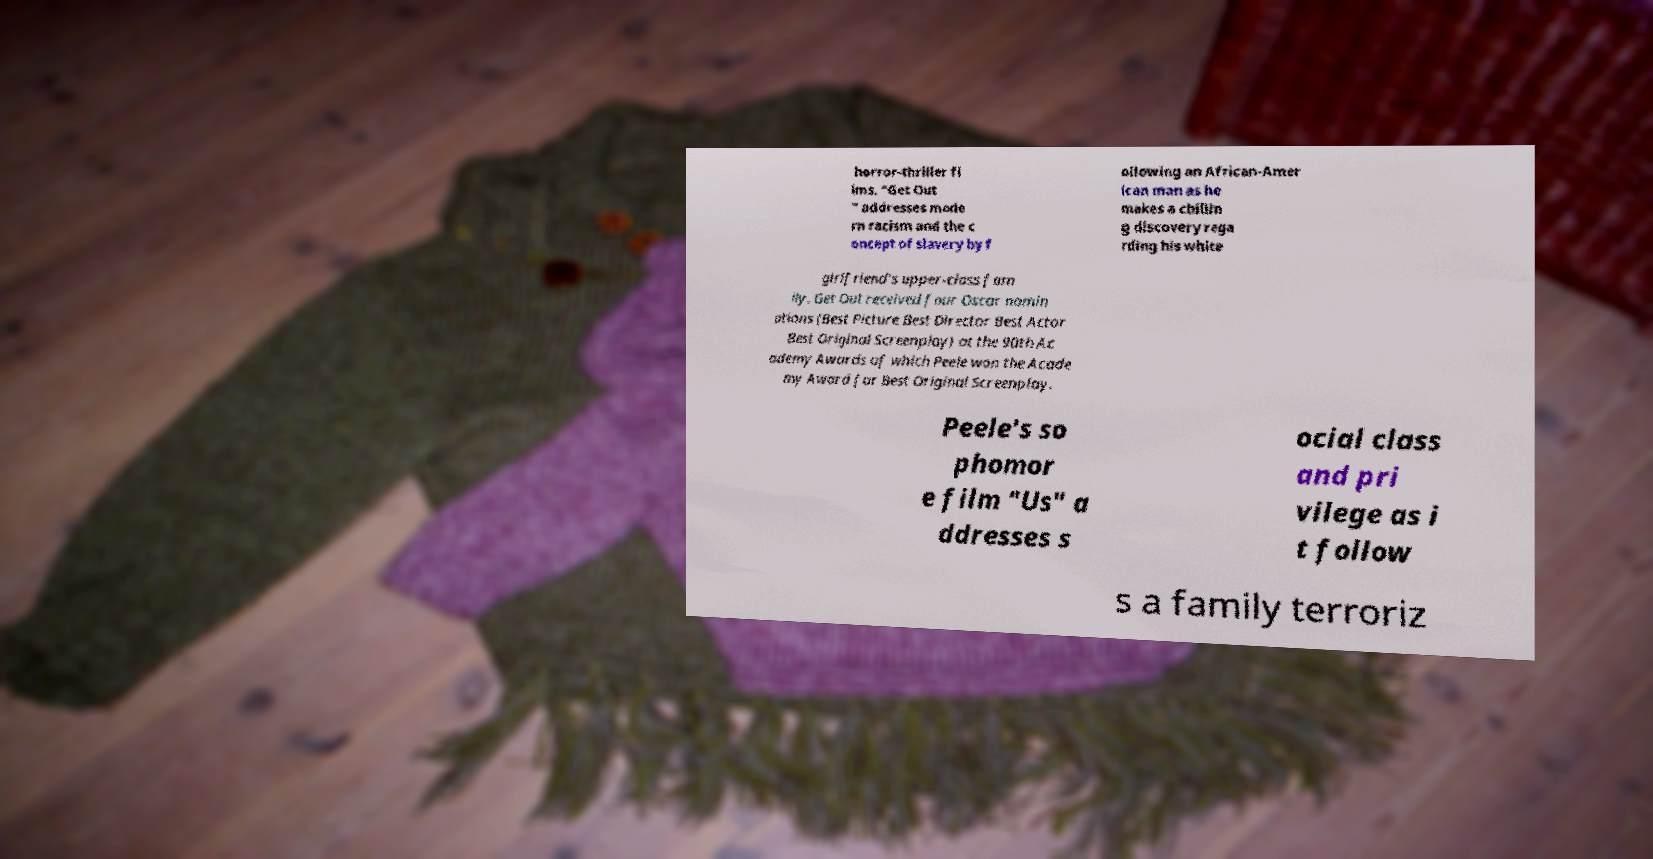Can you read and provide the text displayed in the image?This photo seems to have some interesting text. Can you extract and type it out for me? horror-thriller fi lms. "Get Out " addresses mode rn racism and the c oncept of slavery by f ollowing an African-Amer ican man as he makes a chillin g discovery rega rding his white girlfriend's upper-class fam ily. Get Out received four Oscar nomin ations (Best Picture Best Director Best Actor Best Original Screenplay) at the 90th Ac ademy Awards of which Peele won the Acade my Award for Best Original Screenplay. Peele's so phomor e film "Us" a ddresses s ocial class and pri vilege as i t follow s a family terroriz 